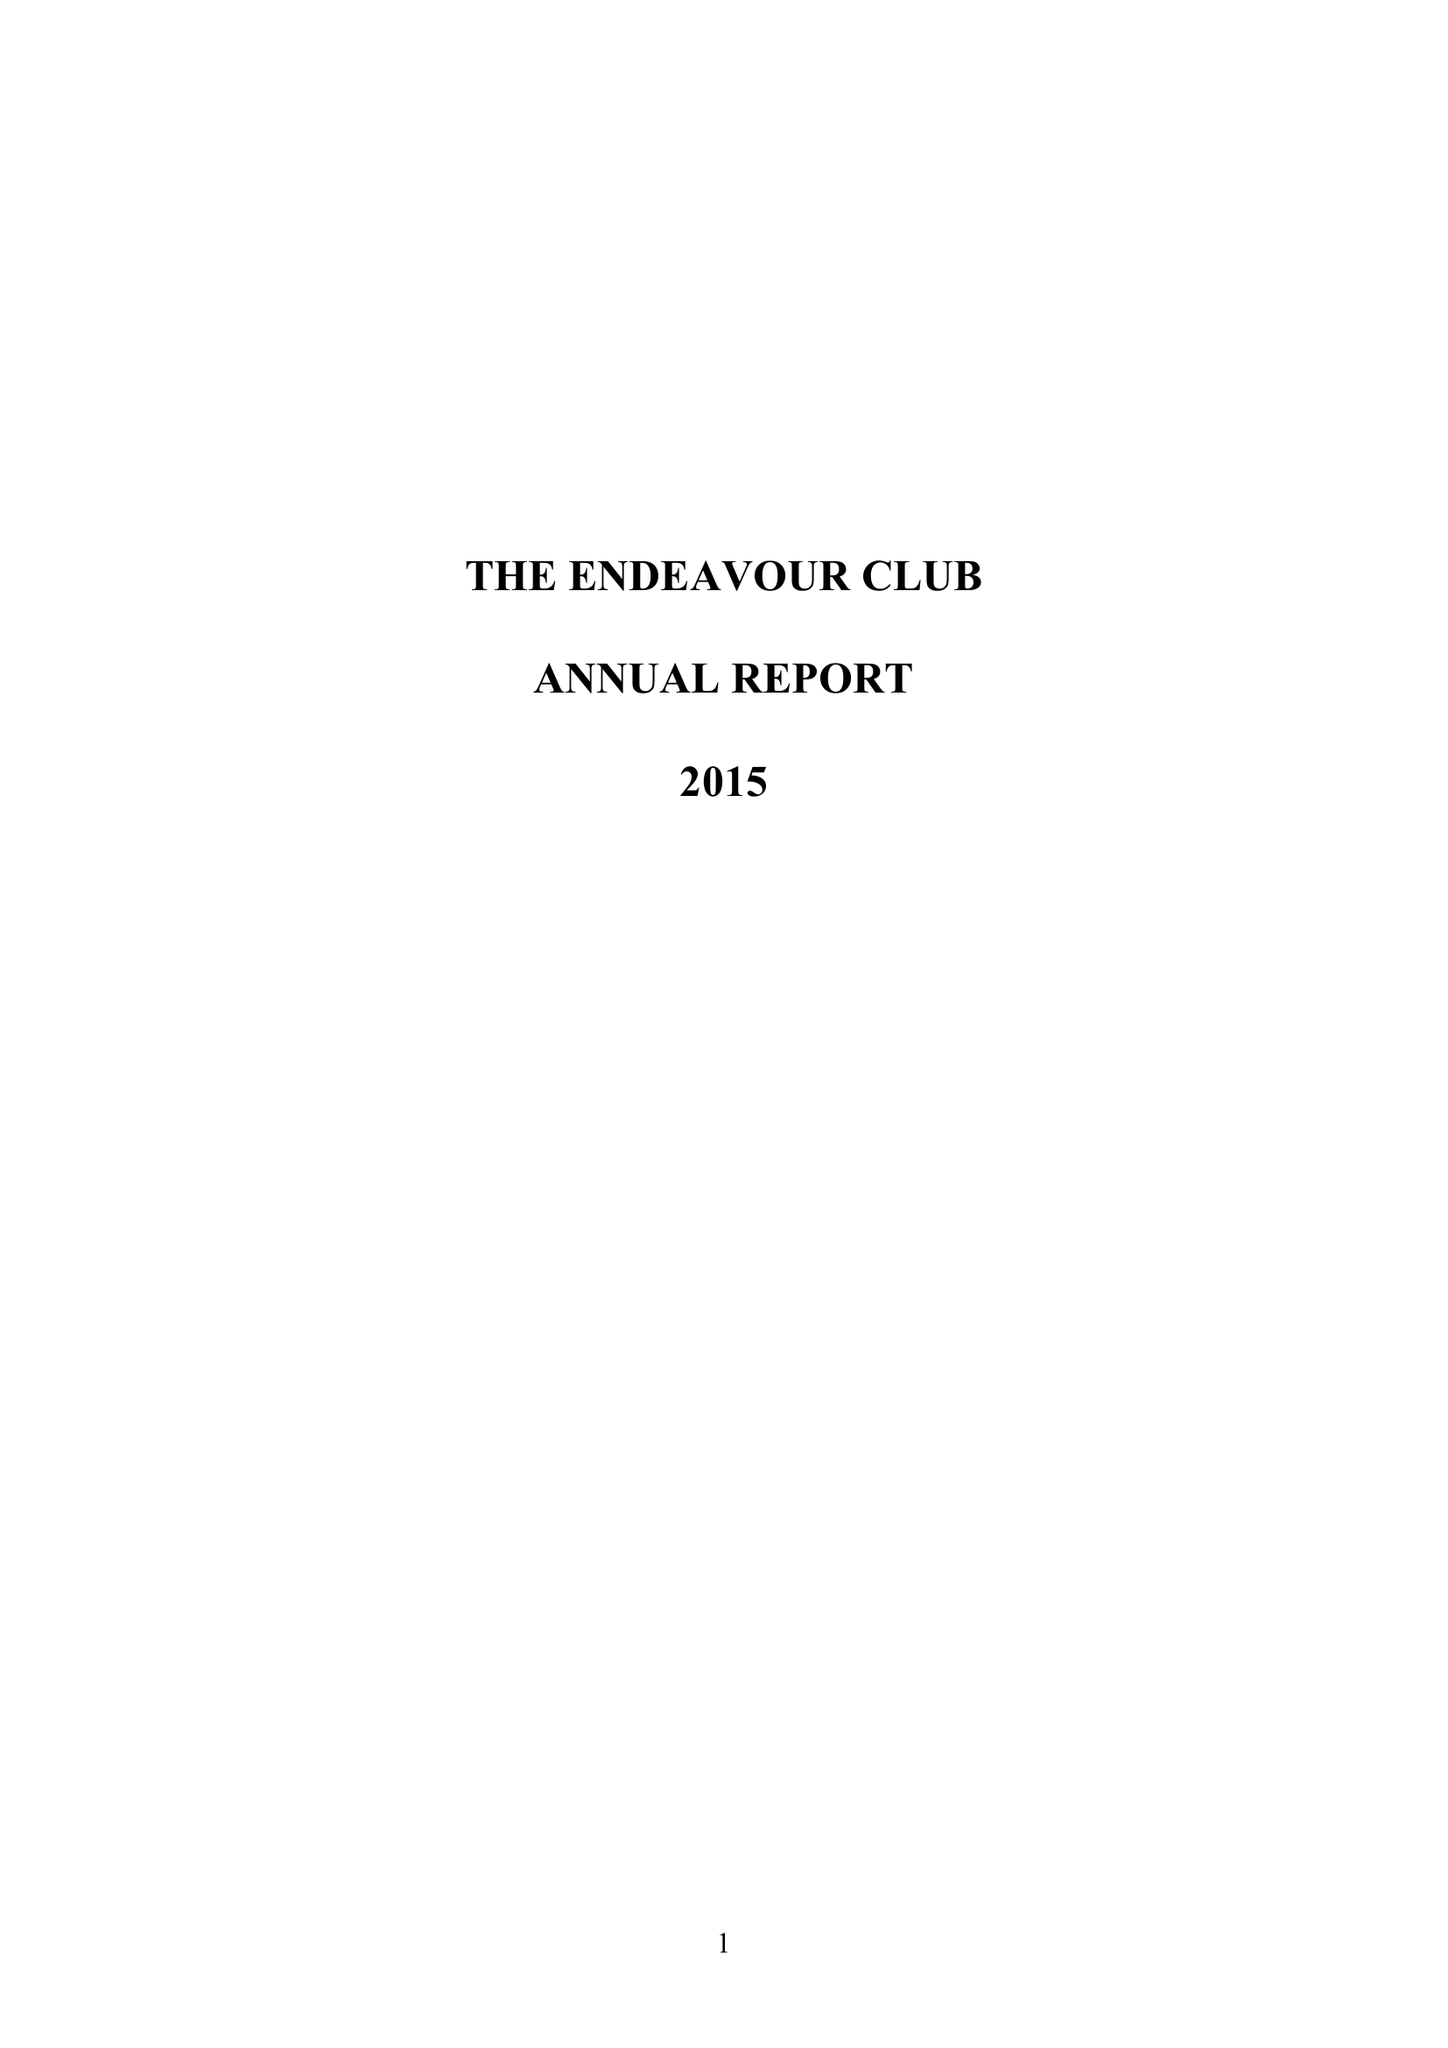What is the value for the address__street_line?
Answer the question using a single word or phrase. MARTIN WAY 